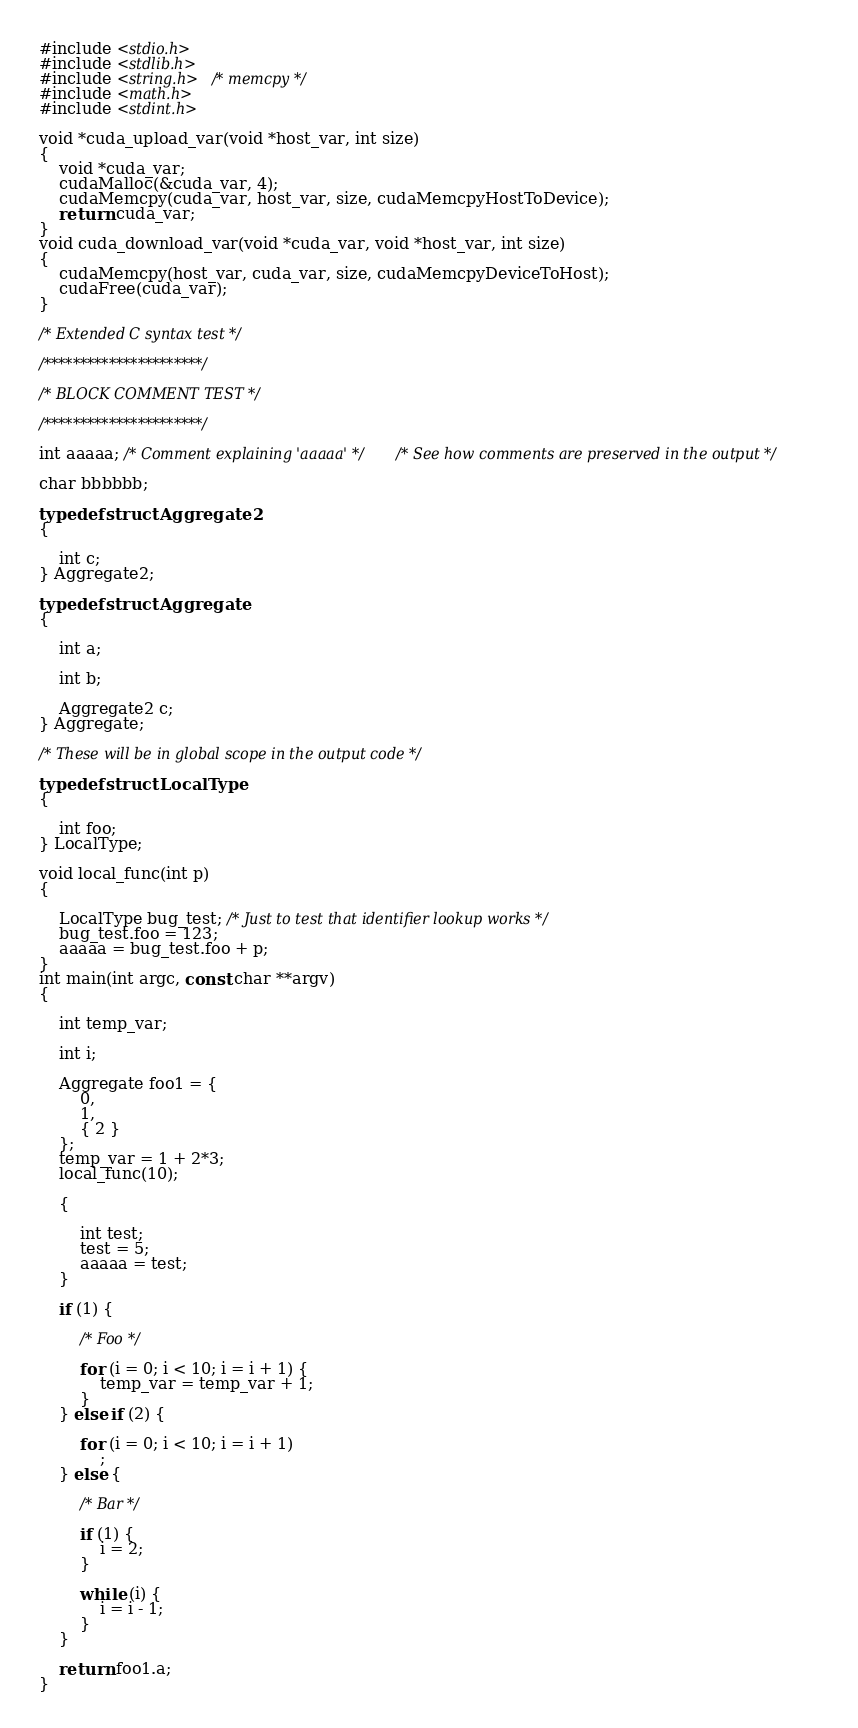Convert code to text. <code><loc_0><loc_0><loc_500><loc_500><_Cuda_>#include <stdio.h>
#include <stdlib.h>
#include <string.h> /* memcpy */
#include <math.h>
#include <stdint.h>

void *cuda_upload_var(void *host_var, int size)
{
	void *cuda_var;
	cudaMalloc(&cuda_var, 4);
	cudaMemcpy(cuda_var, host_var, size, cudaMemcpyHostToDevice);
	return cuda_var;
}
void cuda_download_var(void *cuda_var, void *host_var, int size)
{
	cudaMemcpy(host_var, cuda_var, size, cudaMemcpyDeviceToHost);
	cudaFree(cuda_var);
}

/* Extended C syntax test */

/**********************/

/* BLOCK COMMENT TEST */

/**********************/

int aaaaa; /* Comment explaining 'aaaaa' */ /* See how comments are preserved in the output */

char bbbbbb;

typedef struct Aggregate2
{

    int c;
} Aggregate2;

typedef struct Aggregate
{

    int a;

    int b;

    Aggregate2 c;
} Aggregate;

/* These will be in global scope in the output code */

typedef struct LocalType
{

    int foo;
} LocalType;

void local_func(int p)
{

    LocalType bug_test; /* Just to test that identifier lookup works */
    bug_test.foo = 123;
    aaaaa = bug_test.foo + p;
}
int main(int argc, const char **argv)
{

    int temp_var;

    int i;

    Aggregate foo1 = {
        0,
        1,
        { 2 }
    };
    temp_var = 1 + 2*3;
    local_func(10);

    {

        int test;
        test = 5;
        aaaaa = test;
    }

    if (1) {

        /* Foo */

        for (i = 0; i < 10; i = i + 1) {
            temp_var = temp_var + 1;
        }
    } else if (2) {

        for (i = 0; i < 10; i = i + 1) 
            ;
    } else {

        /* Bar */

        if (1) {
            i = 2;
        }

        while (i) {
            i = i - 1;
        }
    }

    return foo1.a;
}

</code> 